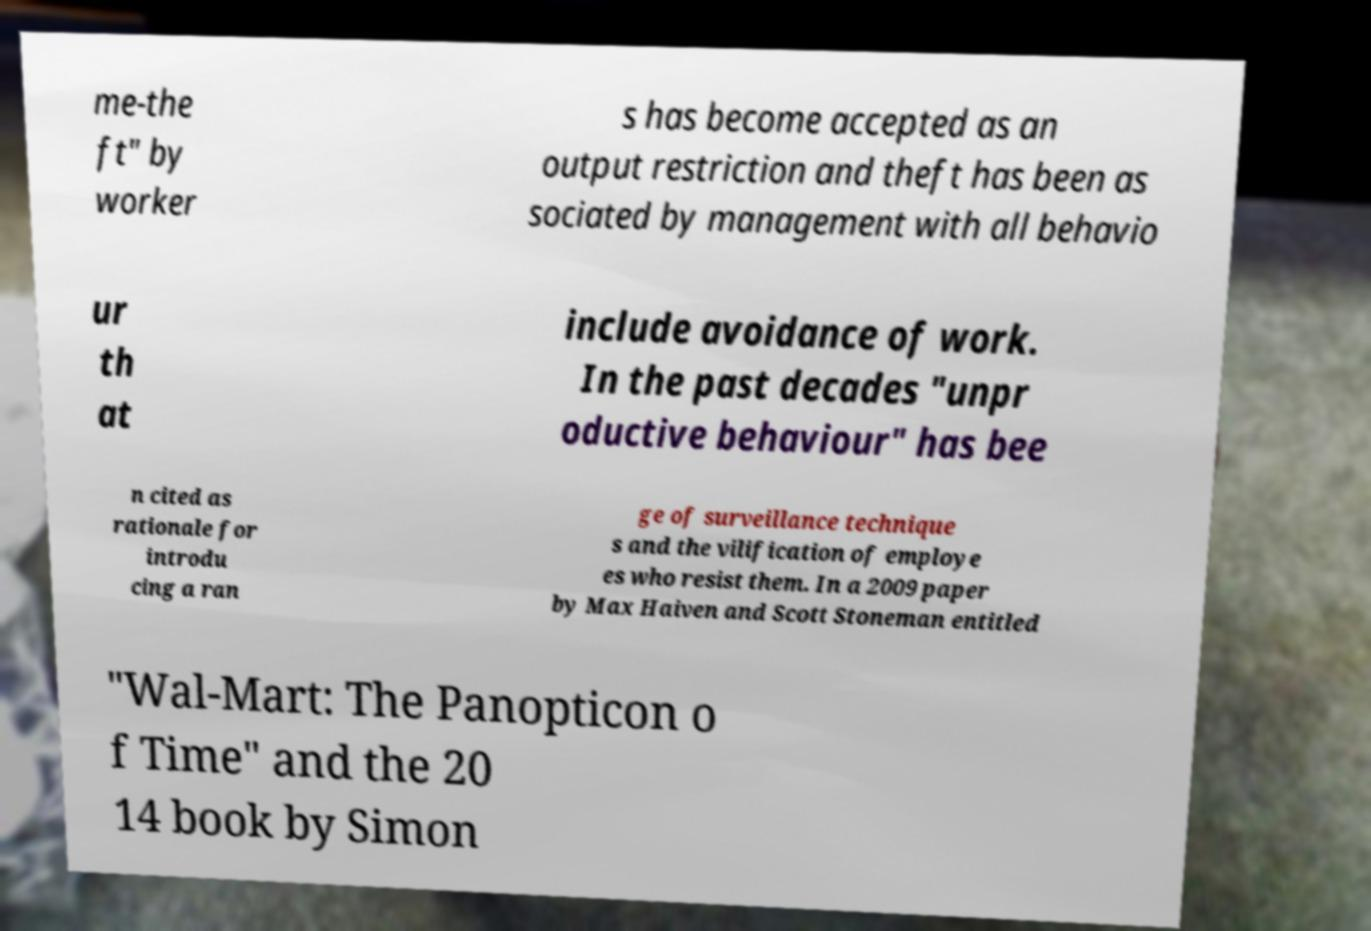Can you read and provide the text displayed in the image?This photo seems to have some interesting text. Can you extract and type it out for me? me-the ft" by worker s has become accepted as an output restriction and theft has been as sociated by management with all behavio ur th at include avoidance of work. In the past decades "unpr oductive behaviour" has bee n cited as rationale for introdu cing a ran ge of surveillance technique s and the vilification of employe es who resist them. In a 2009 paper by Max Haiven and Scott Stoneman entitled "Wal-Mart: The Panopticon o f Time" and the 20 14 book by Simon 